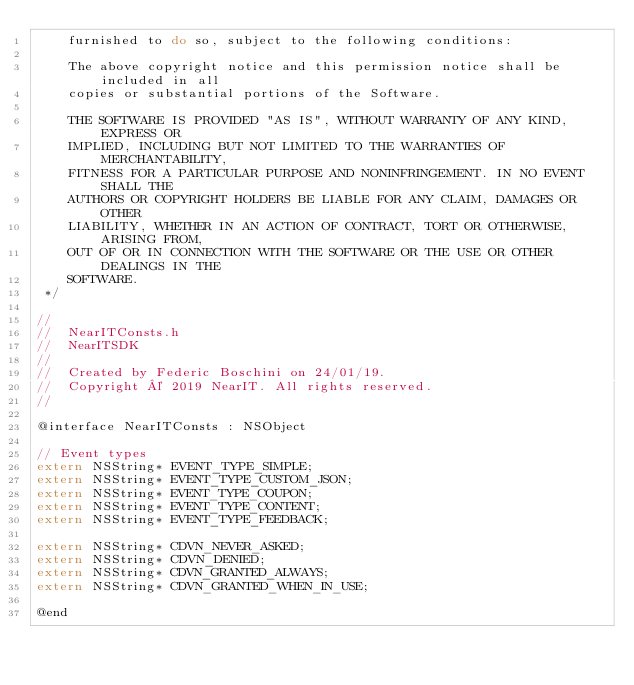Convert code to text. <code><loc_0><loc_0><loc_500><loc_500><_C_>    furnished to do so, subject to the following conditions:

    The above copyright notice and this permission notice shall be included in all
    copies or substantial portions of the Software.

    THE SOFTWARE IS PROVIDED "AS IS", WITHOUT WARRANTY OF ANY KIND, EXPRESS OR
    IMPLIED, INCLUDING BUT NOT LIMITED TO THE WARRANTIES OF MERCHANTABILITY,
    FITNESS FOR A PARTICULAR PURPOSE AND NONINFRINGEMENT. IN NO EVENT SHALL THE
    AUTHORS OR COPYRIGHT HOLDERS BE LIABLE FOR ANY CLAIM, DAMAGES OR OTHER
    LIABILITY, WHETHER IN AN ACTION OF CONTRACT, TORT OR OTHERWISE, ARISING FROM,
    OUT OF OR IN CONNECTION WITH THE SOFTWARE OR THE USE OR OTHER DEALINGS IN THE
    SOFTWARE.
 */

//
//  NearITConsts.h
//  NearITSDK
//
//  Created by Federic Boschini on 24/01/19.
//  Copyright © 2019 NearIT. All rights reserved.
//
 
@interface NearITConsts : NSObject

// Event types
extern NSString* EVENT_TYPE_SIMPLE;
extern NSString* EVENT_TYPE_CUSTOM_JSON;
extern NSString* EVENT_TYPE_COUPON;
extern NSString* EVENT_TYPE_CONTENT;
extern NSString* EVENT_TYPE_FEEDBACK;

extern NSString* CDVN_NEVER_ASKED;
extern NSString* CDVN_DENIED;
extern NSString* CDVN_GRANTED_ALWAYS;
extern NSString* CDVN_GRANTED_WHEN_IN_USE;

@end
</code> 